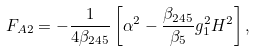<formula> <loc_0><loc_0><loc_500><loc_500>F _ { A 2 } = - \frac { 1 } { 4 \beta _ { 2 4 5 } } \left [ \alpha ^ { 2 } - \frac { \beta _ { 2 4 5 } } { \beta _ { 5 } } g _ { 1 } ^ { 2 } H ^ { 2 } \right ] ,</formula> 